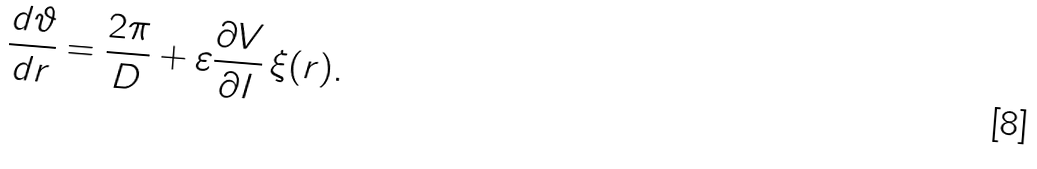Convert formula to latex. <formula><loc_0><loc_0><loc_500><loc_500>\frac { d \vartheta } { d r } = \frac { 2 \pi } { D } + \varepsilon \frac { \partial V } { \partial I } \, \xi ( r ) .</formula> 